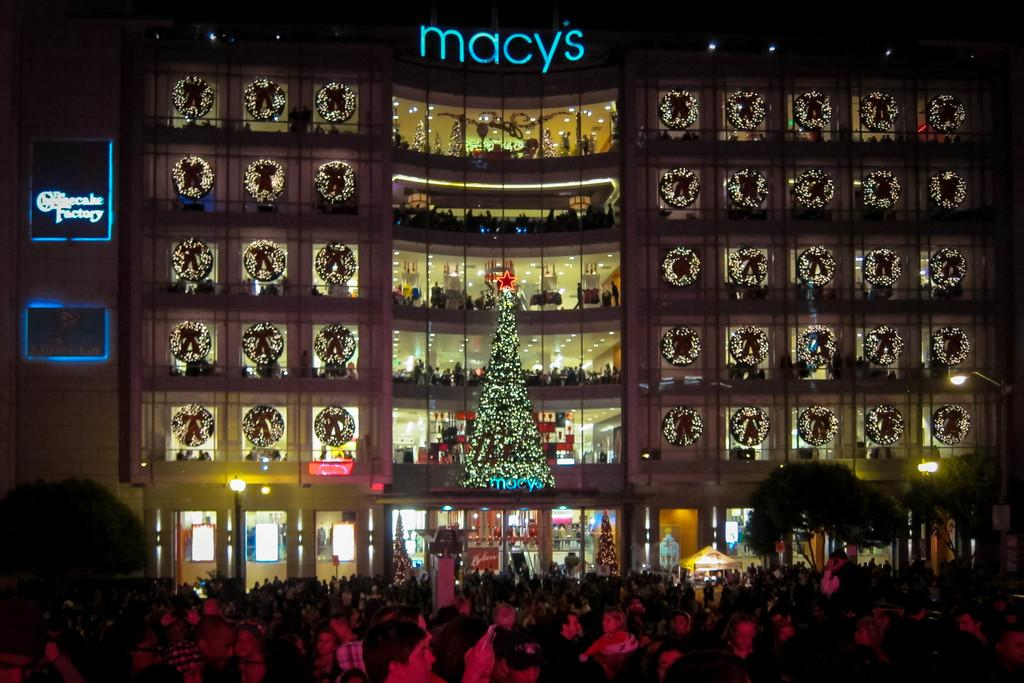What is the main structure in the center of the image? There is a building in the center of the image. How is the building decorated? The building is decorated with decors. What is located in the center of the image besides the building? There is an xmas tree in the center of the image. What can be seen at the bottom of the image? There is a crowd at the bottom of the image. What type of vegetation is visible in the image? Trees are visible in the image. What type of tray is being used by the crowd to play volleyball in the image? There is no tray or volleyball present in the image. How does the hose contribute to the decoration of the building in the image? There is no hose present in the image. 